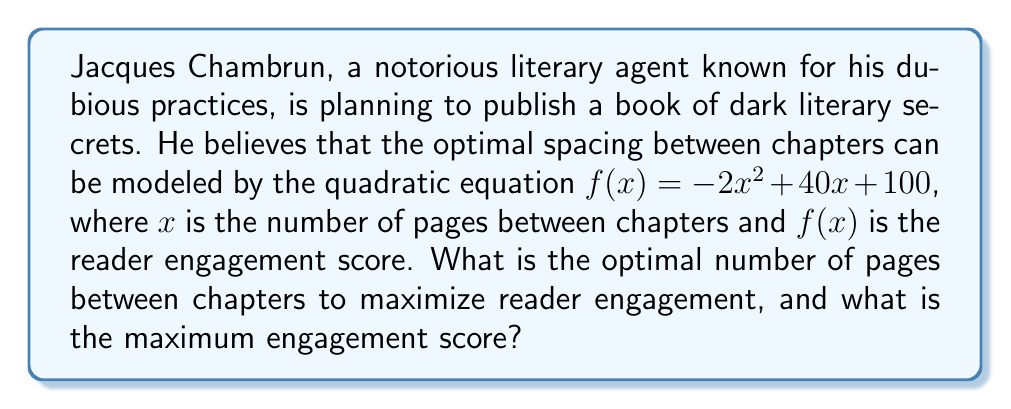Provide a solution to this math problem. To solve this problem, we need to find the vertex of the parabola represented by the quadratic equation. The vertex will give us the maximum point of the function, which corresponds to the optimal spacing and maximum engagement score.

1) The quadratic equation is in the form $f(x) = ax^2 + bx + c$, where:
   $a = -2$, $b = 40$, and $c = 100$

2) For a quadratic equation in this form, the x-coordinate of the vertex is given by $x = -\frac{b}{2a}$

3) Substituting our values:
   $x = -\frac{40}{2(-2)} = -\frac{40}{-4} = 10$

4) To find the maximum engagement score, we need to calculate $f(10)$:
   $f(10) = -2(10)^2 + 40(10) + 100$
   $= -2(100) + 400 + 100$
   $= -200 + 400 + 100$
   $= 300$

Therefore, the optimal number of pages between chapters is 10, and the maximum engagement score is 300.
Answer: Optimal spacing: 10 pages
Maximum engagement score: 300 